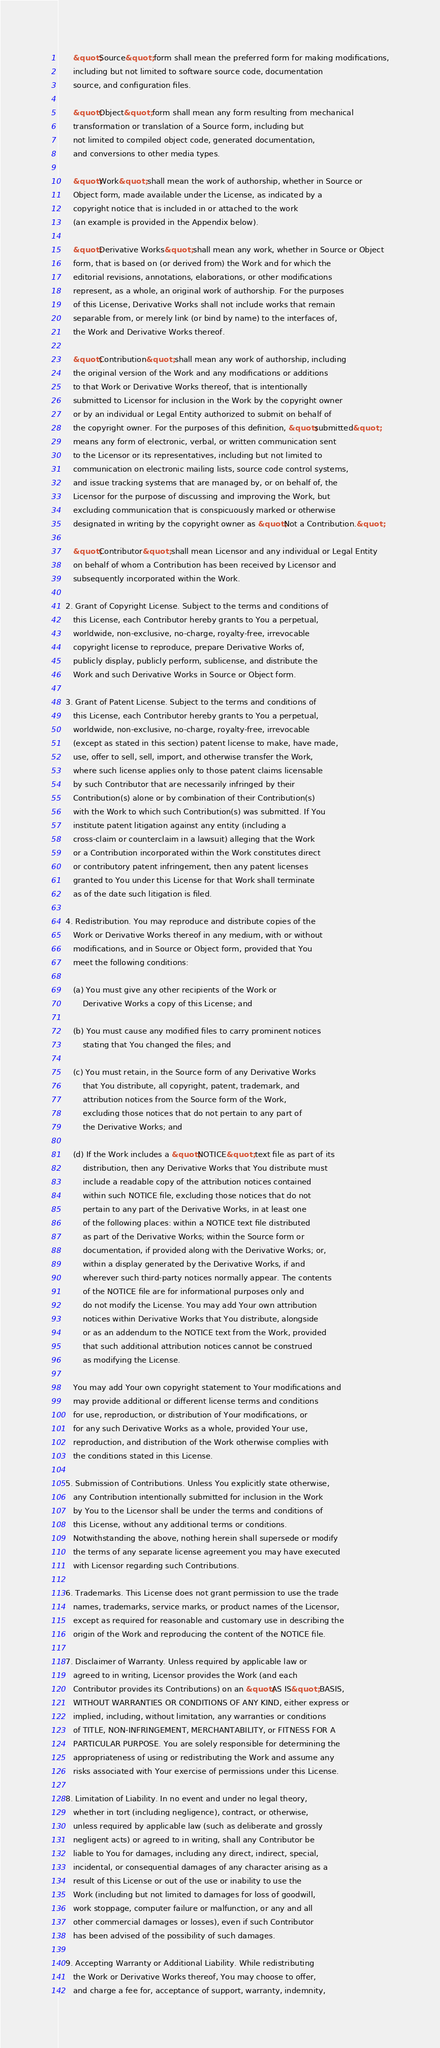<code> <loc_0><loc_0><loc_500><loc_500><_HTML_>
      &quot;Source&quot; form shall mean the preferred form for making modifications,
      including but not limited to software source code, documentation
      source, and configuration files.

      &quot;Object&quot; form shall mean any form resulting from mechanical
      transformation or translation of a Source form, including but
      not limited to compiled object code, generated documentation,
      and conversions to other media types.

      &quot;Work&quot; shall mean the work of authorship, whether in Source or
      Object form, made available under the License, as indicated by a
      copyright notice that is included in or attached to the work
      (an example is provided in the Appendix below).

      &quot;Derivative Works&quot; shall mean any work, whether in Source or Object
      form, that is based on (or derived from) the Work and for which the
      editorial revisions, annotations, elaborations, or other modifications
      represent, as a whole, an original work of authorship. For the purposes
      of this License, Derivative Works shall not include works that remain
      separable from, or merely link (or bind by name) to the interfaces of,
      the Work and Derivative Works thereof.

      &quot;Contribution&quot; shall mean any work of authorship, including
      the original version of the Work and any modifications or additions
      to that Work or Derivative Works thereof, that is intentionally
      submitted to Licensor for inclusion in the Work by the copyright owner
      or by an individual or Legal Entity authorized to submit on behalf of
      the copyright owner. For the purposes of this definition, &quot;submitted&quot;
      means any form of electronic, verbal, or written communication sent
      to the Licensor or its representatives, including but not limited to
      communication on electronic mailing lists, source code control systems,
      and issue tracking systems that are managed by, or on behalf of, the
      Licensor for the purpose of discussing and improving the Work, but
      excluding communication that is conspicuously marked or otherwise
      designated in writing by the copyright owner as &quot;Not a Contribution.&quot;

      &quot;Contributor&quot; shall mean Licensor and any individual or Legal Entity
      on behalf of whom a Contribution has been received by Licensor and
      subsequently incorporated within the Work.

   2. Grant of Copyright License. Subject to the terms and conditions of
      this License, each Contributor hereby grants to You a perpetual,
      worldwide, non-exclusive, no-charge, royalty-free, irrevocable
      copyright license to reproduce, prepare Derivative Works of,
      publicly display, publicly perform, sublicense, and distribute the
      Work and such Derivative Works in Source or Object form.

   3. Grant of Patent License. Subject to the terms and conditions of
      this License, each Contributor hereby grants to You a perpetual,
      worldwide, non-exclusive, no-charge, royalty-free, irrevocable
      (except as stated in this section) patent license to make, have made,
      use, offer to sell, sell, import, and otherwise transfer the Work,
      where such license applies only to those patent claims licensable
      by such Contributor that are necessarily infringed by their
      Contribution(s) alone or by combination of their Contribution(s)
      with the Work to which such Contribution(s) was submitted. If You
      institute patent litigation against any entity (including a
      cross-claim or counterclaim in a lawsuit) alleging that the Work
      or a Contribution incorporated within the Work constitutes direct
      or contributory patent infringement, then any patent licenses
      granted to You under this License for that Work shall terminate
      as of the date such litigation is filed.

   4. Redistribution. You may reproduce and distribute copies of the
      Work or Derivative Works thereof in any medium, with or without
      modifications, and in Source or Object form, provided that You
      meet the following conditions:

      (a) You must give any other recipients of the Work or
          Derivative Works a copy of this License; and

      (b) You must cause any modified files to carry prominent notices
          stating that You changed the files; and

      (c) You must retain, in the Source form of any Derivative Works
          that You distribute, all copyright, patent, trademark, and
          attribution notices from the Source form of the Work,
          excluding those notices that do not pertain to any part of
          the Derivative Works; and

      (d) If the Work includes a &quot;NOTICE&quot; text file as part of its
          distribution, then any Derivative Works that You distribute must
          include a readable copy of the attribution notices contained
          within such NOTICE file, excluding those notices that do not
          pertain to any part of the Derivative Works, in at least one
          of the following places: within a NOTICE text file distributed
          as part of the Derivative Works; within the Source form or
          documentation, if provided along with the Derivative Works; or,
          within a display generated by the Derivative Works, if and
          wherever such third-party notices normally appear. The contents
          of the NOTICE file are for informational purposes only and
          do not modify the License. You may add Your own attribution
          notices within Derivative Works that You distribute, alongside
          or as an addendum to the NOTICE text from the Work, provided
          that such additional attribution notices cannot be construed
          as modifying the License.

      You may add Your own copyright statement to Your modifications and
      may provide additional or different license terms and conditions
      for use, reproduction, or distribution of Your modifications, or
      for any such Derivative Works as a whole, provided Your use,
      reproduction, and distribution of the Work otherwise complies with
      the conditions stated in this License.

   5. Submission of Contributions. Unless You explicitly state otherwise,
      any Contribution intentionally submitted for inclusion in the Work
      by You to the Licensor shall be under the terms and conditions of
      this License, without any additional terms or conditions.
      Notwithstanding the above, nothing herein shall supersede or modify
      the terms of any separate license agreement you may have executed
      with Licensor regarding such Contributions.

   6. Trademarks. This License does not grant permission to use the trade
      names, trademarks, service marks, or product names of the Licensor,
      except as required for reasonable and customary use in describing the
      origin of the Work and reproducing the content of the NOTICE file.

   7. Disclaimer of Warranty. Unless required by applicable law or
      agreed to in writing, Licensor provides the Work (and each
      Contributor provides its Contributions) on an &quot;AS IS&quot; BASIS,
      WITHOUT WARRANTIES OR CONDITIONS OF ANY KIND, either express or
      implied, including, without limitation, any warranties or conditions
      of TITLE, NON-INFRINGEMENT, MERCHANTABILITY, or FITNESS FOR A
      PARTICULAR PURPOSE. You are solely responsible for determining the
      appropriateness of using or redistributing the Work and assume any
      risks associated with Your exercise of permissions under this License.

   8. Limitation of Liability. In no event and under no legal theory,
      whether in tort (including negligence), contract, or otherwise,
      unless required by applicable law (such as deliberate and grossly
      negligent acts) or agreed to in writing, shall any Contributor be
      liable to You for damages, including any direct, indirect, special,
      incidental, or consequential damages of any character arising as a
      result of this License or out of the use or inability to use the
      Work (including but not limited to damages for loss of goodwill,
      work stoppage, computer failure or malfunction, or any and all
      other commercial damages or losses), even if such Contributor
      has been advised of the possibility of such damages.

   9. Accepting Warranty or Additional Liability. While redistributing
      the Work or Derivative Works thereof, You may choose to offer,
      and charge a fee for, acceptance of support, warranty, indemnity,</code> 